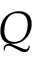<formula> <loc_0><loc_0><loc_500><loc_500>Q</formula> 